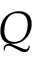<formula> <loc_0><loc_0><loc_500><loc_500>Q</formula> 